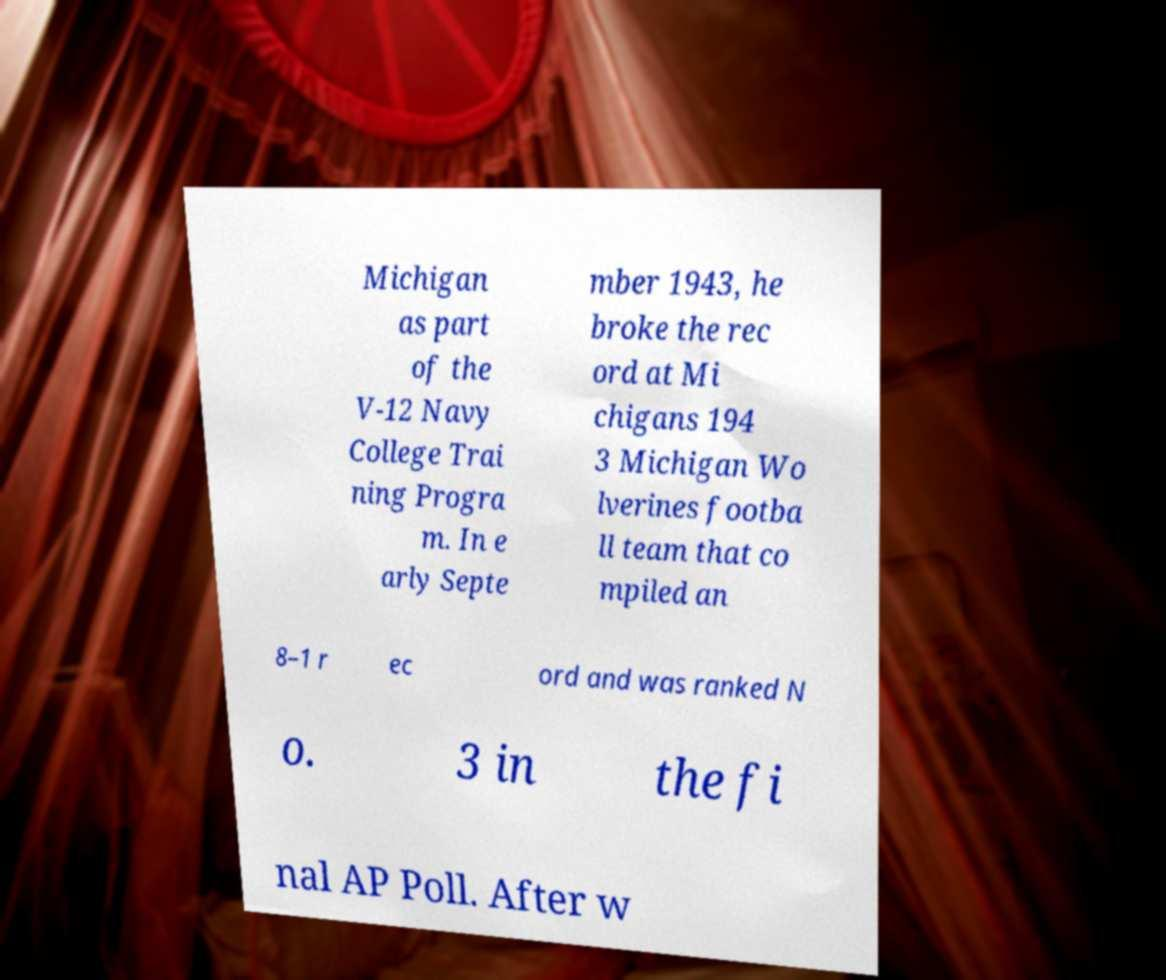Can you accurately transcribe the text from the provided image for me? Michigan as part of the V-12 Navy College Trai ning Progra m. In e arly Septe mber 1943, he broke the rec ord at Mi chigans 194 3 Michigan Wo lverines footba ll team that co mpiled an 8–1 r ec ord and was ranked N o. 3 in the fi nal AP Poll. After w 